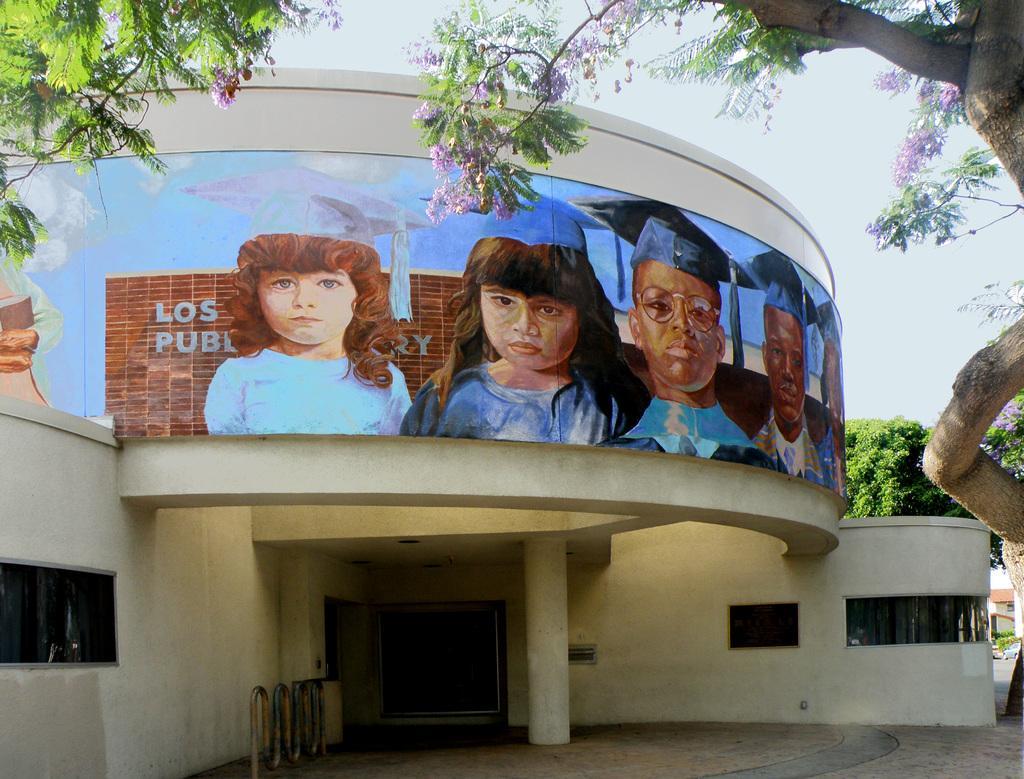Could you give a brief overview of what you see in this image? In the image there is a building and there are few paintings of the children on the building, there is a tall tree with purple flowers on the right side. 